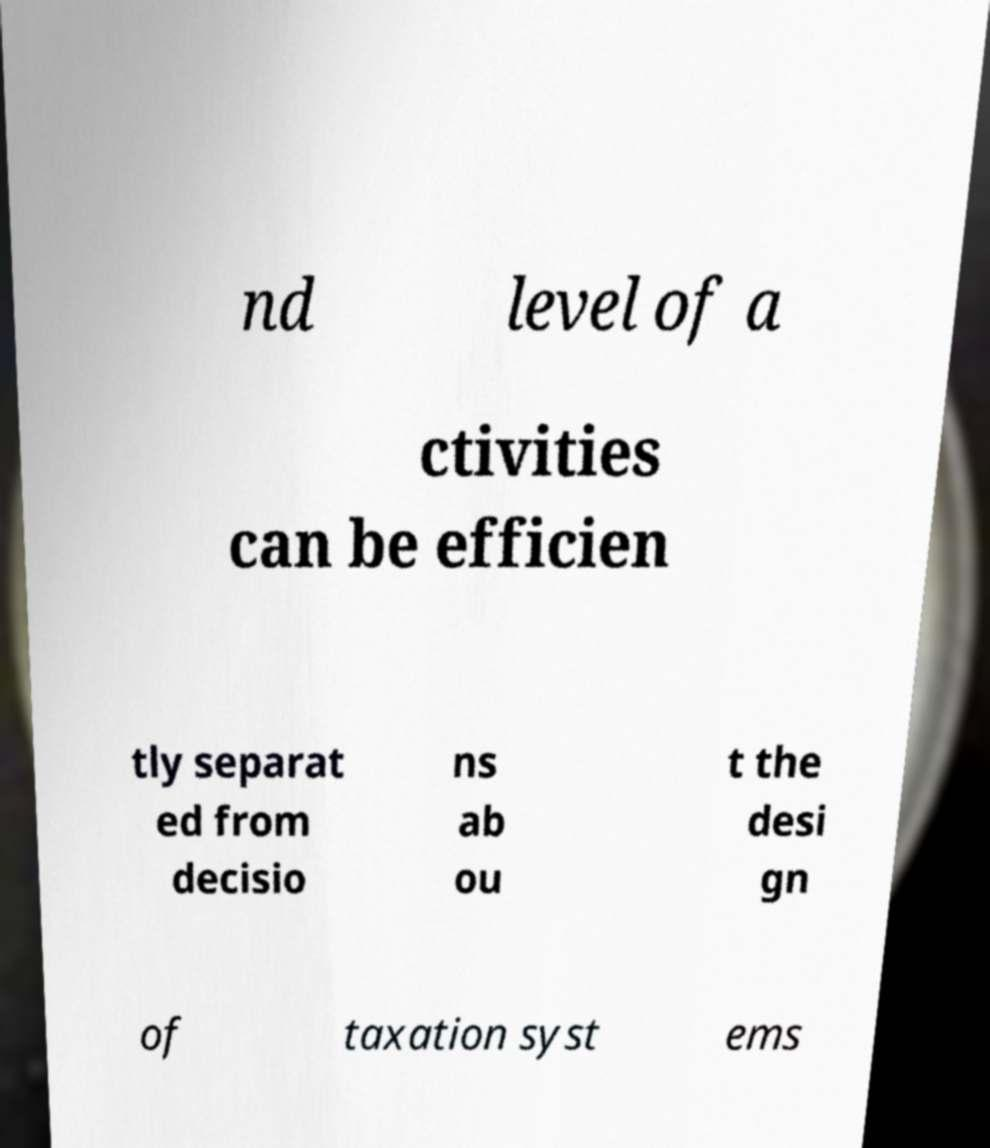For documentation purposes, I need the text within this image transcribed. Could you provide that? nd level of a ctivities can be efficien tly separat ed from decisio ns ab ou t the desi gn of taxation syst ems 